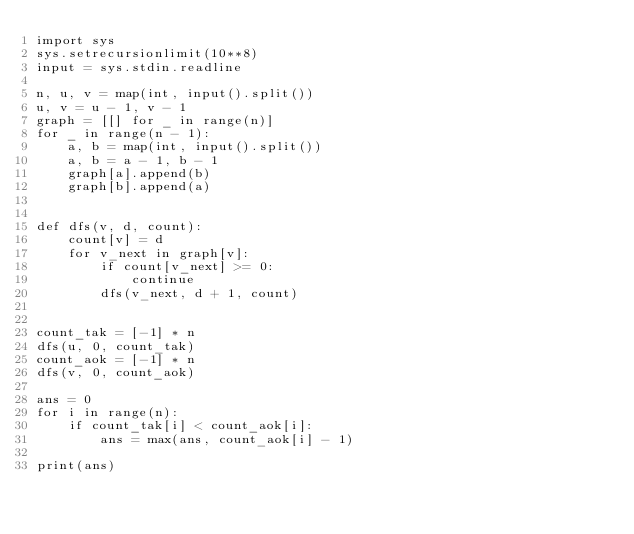Convert code to text. <code><loc_0><loc_0><loc_500><loc_500><_Python_>import sys
sys.setrecursionlimit(10**8)
input = sys.stdin.readline

n, u, v = map(int, input().split())
u, v = u - 1, v - 1
graph = [[] for _ in range(n)]
for _ in range(n - 1):
    a, b = map(int, input().split())
    a, b = a - 1, b - 1
    graph[a].append(b)
    graph[b].append(a)


def dfs(v, d, count):
    count[v] = d
    for v_next in graph[v]:
        if count[v_next] >= 0:
            continue
        dfs(v_next, d + 1, count)


count_tak = [-1] * n
dfs(u, 0, count_tak)
count_aok = [-1] * n
dfs(v, 0, count_aok)

ans = 0
for i in range(n):
    if count_tak[i] < count_aok[i]:
        ans = max(ans, count_aok[i] - 1)

print(ans)
</code> 